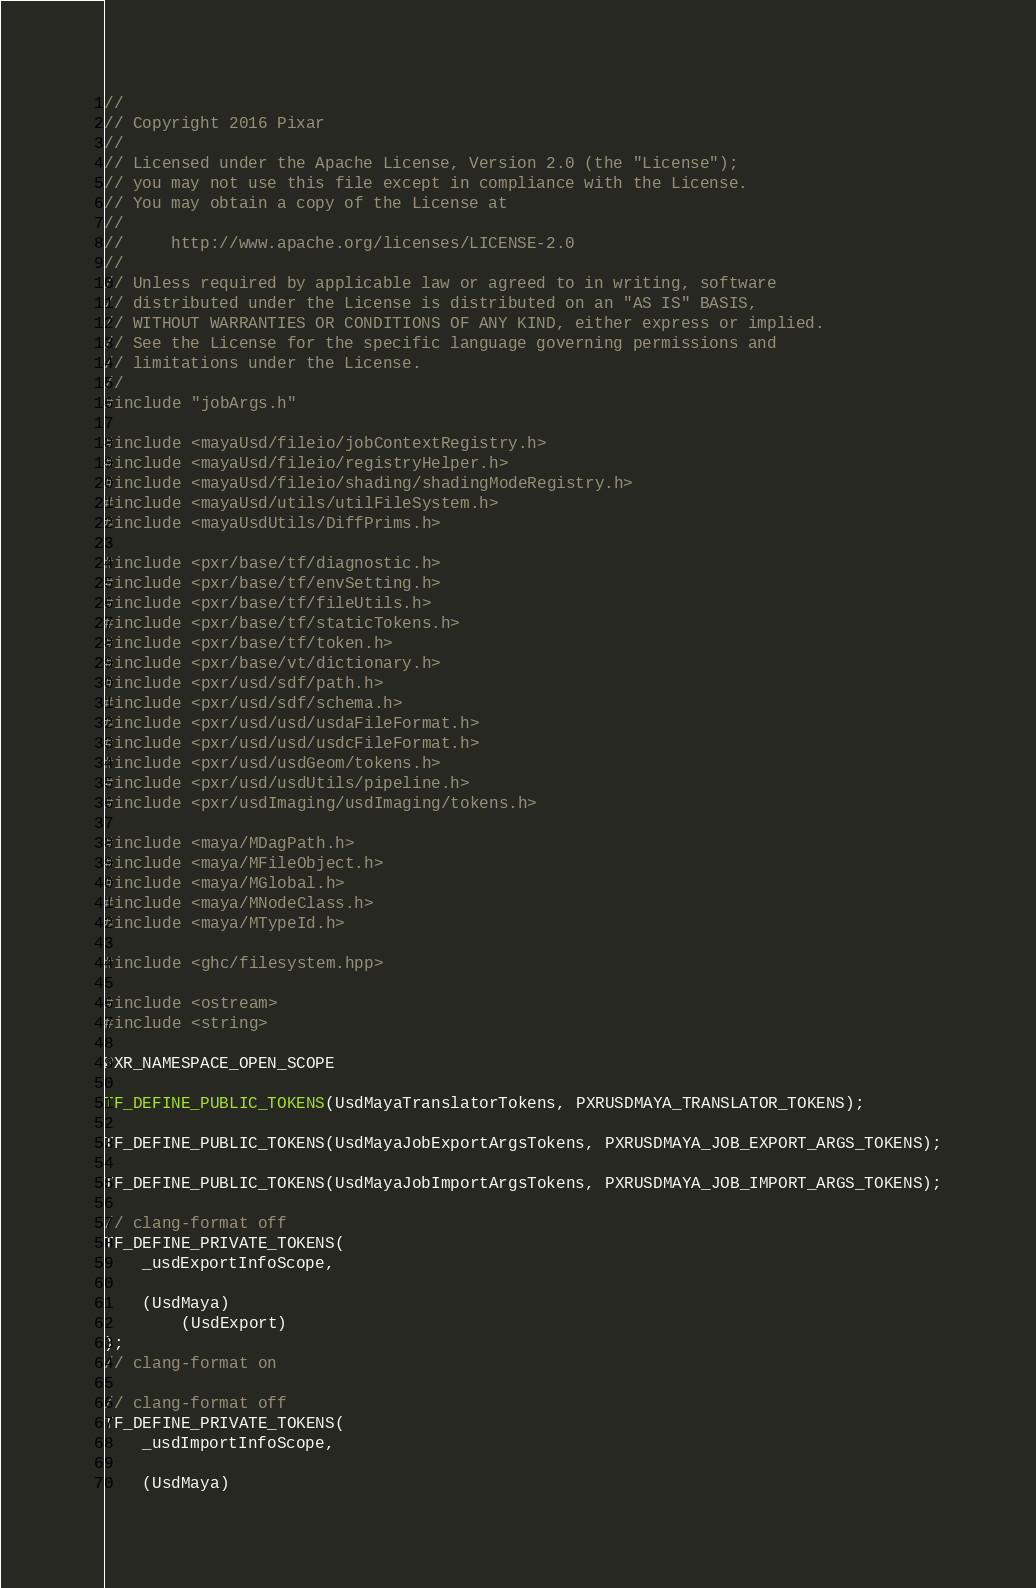<code> <loc_0><loc_0><loc_500><loc_500><_C++_>//
// Copyright 2016 Pixar
//
// Licensed under the Apache License, Version 2.0 (the "License");
// you may not use this file except in compliance with the License.
// You may obtain a copy of the License at
//
//     http://www.apache.org/licenses/LICENSE-2.0
//
// Unless required by applicable law or agreed to in writing, software
// distributed under the License is distributed on an "AS IS" BASIS,
// WITHOUT WARRANTIES OR CONDITIONS OF ANY KIND, either express or implied.
// See the License for the specific language governing permissions and
// limitations under the License.
//
#include "jobArgs.h"

#include <mayaUsd/fileio/jobContextRegistry.h>
#include <mayaUsd/fileio/registryHelper.h>
#include <mayaUsd/fileio/shading/shadingModeRegistry.h>
#include <mayaUsd/utils/utilFileSystem.h>
#include <mayaUsdUtils/DiffPrims.h>

#include <pxr/base/tf/diagnostic.h>
#include <pxr/base/tf/envSetting.h>
#include <pxr/base/tf/fileUtils.h>
#include <pxr/base/tf/staticTokens.h>
#include <pxr/base/tf/token.h>
#include <pxr/base/vt/dictionary.h>
#include <pxr/usd/sdf/path.h>
#include <pxr/usd/sdf/schema.h>
#include <pxr/usd/usd/usdaFileFormat.h>
#include <pxr/usd/usd/usdcFileFormat.h>
#include <pxr/usd/usdGeom/tokens.h>
#include <pxr/usd/usdUtils/pipeline.h>
#include <pxr/usdImaging/usdImaging/tokens.h>

#include <maya/MDagPath.h>
#include <maya/MFileObject.h>
#include <maya/MGlobal.h>
#include <maya/MNodeClass.h>
#include <maya/MTypeId.h>

#include <ghc/filesystem.hpp>

#include <ostream>
#include <string>

PXR_NAMESPACE_OPEN_SCOPE

TF_DEFINE_PUBLIC_TOKENS(UsdMayaTranslatorTokens, PXRUSDMAYA_TRANSLATOR_TOKENS);

TF_DEFINE_PUBLIC_TOKENS(UsdMayaJobExportArgsTokens, PXRUSDMAYA_JOB_EXPORT_ARGS_TOKENS);

TF_DEFINE_PUBLIC_TOKENS(UsdMayaJobImportArgsTokens, PXRUSDMAYA_JOB_IMPORT_ARGS_TOKENS);

// clang-format off
TF_DEFINE_PRIVATE_TOKENS(
    _usdExportInfoScope,

    (UsdMaya)
        (UsdExport)
);
// clang-format on

// clang-format off
TF_DEFINE_PRIVATE_TOKENS(
    _usdImportInfoScope,

    (UsdMaya)</code> 